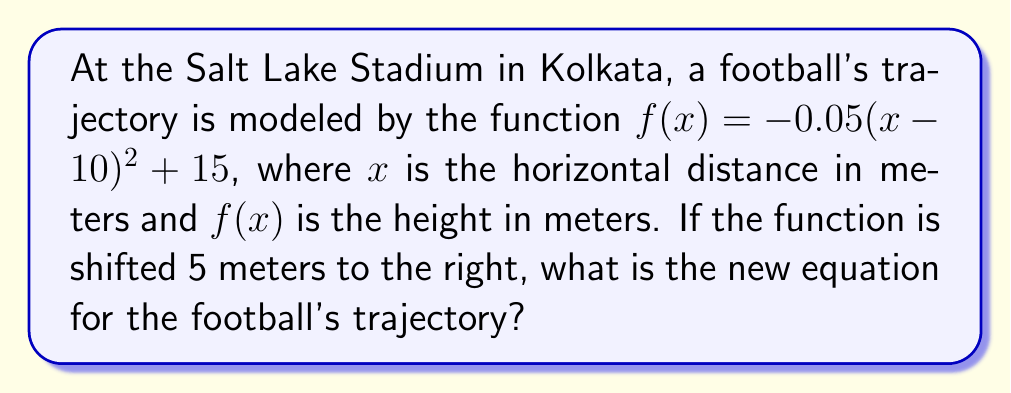Can you answer this question? To determine the horizontal shift of the football's trajectory function, we need to follow these steps:

1) The original function is $f(x) = -0.05(x-10)^2 + 15$

2) A horizontal shift of 5 meters to the right is represented by replacing every $x$ in the original function with $(x-5)$

3) Let's call our new function $g(x)$. So:
   $g(x) = -0.05((x-5)-10)^2 + 15$

4) Simplify the expression inside the parentheses:
   $g(x) = -0.05(x-15)^2 + 15$

5) This is our final equation. The football's trajectory has been shifted 5 meters to the right, changing the point of symmetry from $x=10$ to $x=15$
Answer: $g(x) = -0.05(x-15)^2 + 15$ 